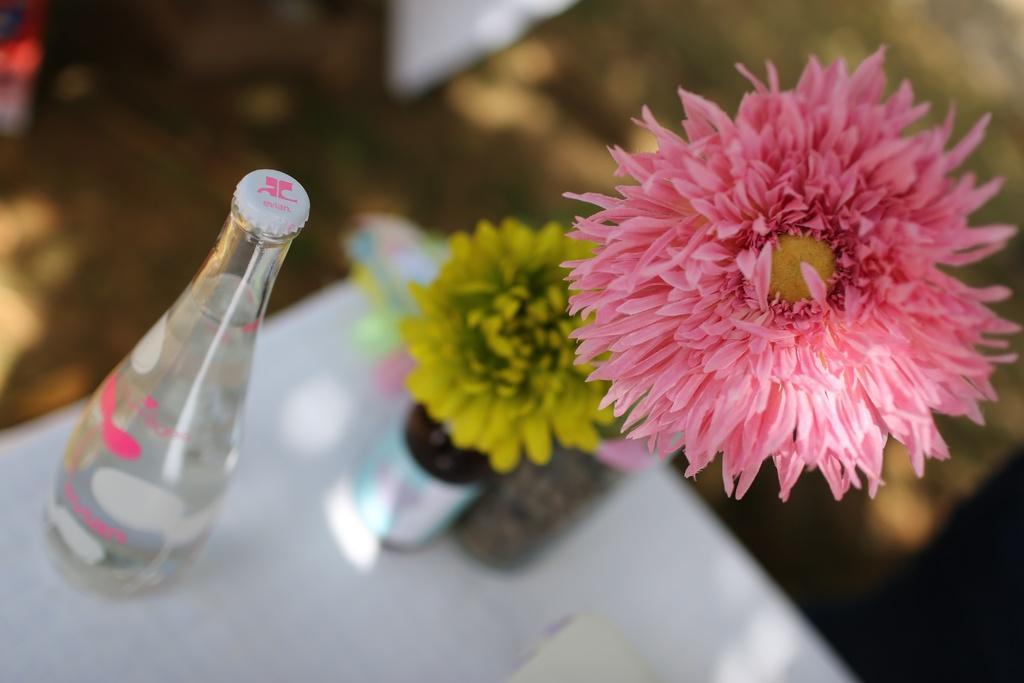Can you describe this image briefly? This picture shows a water bottle and two flowers on the table a flower is pink in colour and other one is yellow in colour 